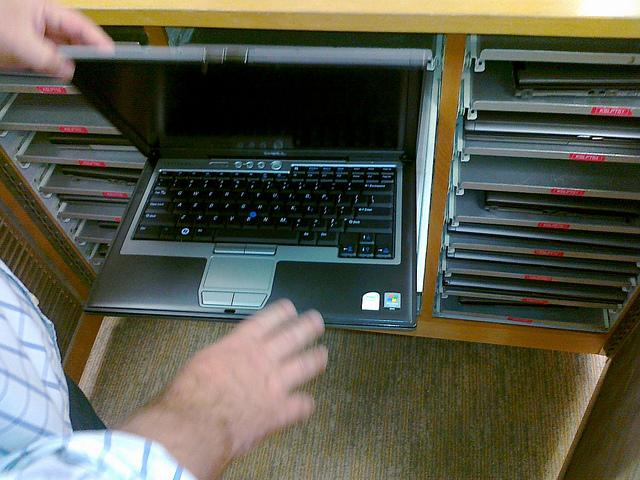What word is associated with the item the person is touching? laptop 